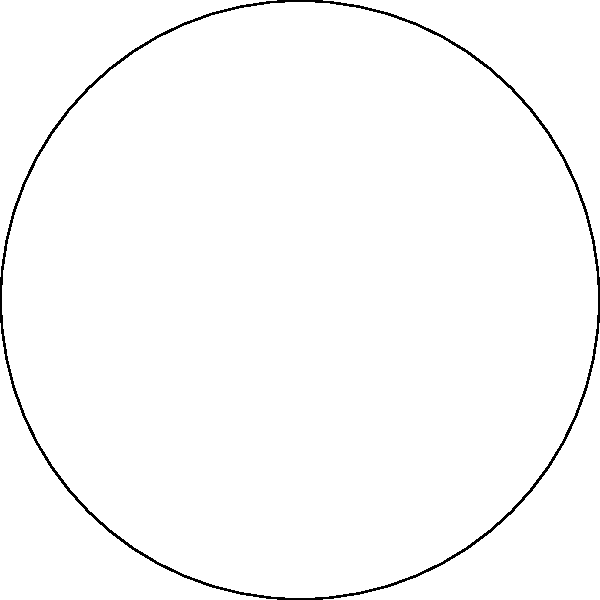A commuter who often cuts it close to their work start time analyzes their route using a polar sector diagram. The diagram shows the probability of encountering red lights at different stages of their commute. If the commuter needs to pass through all four stages without hitting any red lights to arrive on time, what is the probability of making it to work without being late? To solve this problem, we need to follow these steps:

1. Identify the probabilities of encountering green lights (not red) at each stage:
   Stage 1: $1 - 0.15 = 0.85$ or $85\%$
   Stage 2: $1 - 0.25 = 0.75$ or $75\%$
   Stage 3: $1 - 0.25 = 0.75$ or $75\%$
   Stage 4: $1 - 0.35 = 0.65$ or $65\%$

2. To arrive on time, the commuter needs to encounter green lights at all stages. This is a case of independent events, so we multiply the probabilities:

   $P(\text{on time}) = 0.85 \times 0.75 \times 0.75 \times 0.65$

3. Calculate the result:
   $P(\text{on time}) = 0.85 \times 0.75 \times 0.75 \times 0.65 = 0.31078125$

4. Convert to a percentage:
   $0.31078125 \times 100\% \approx 31.08\%$

Therefore, the probability of making it to work without being late is approximately 31.08%.
Answer: $31.08\%$ 